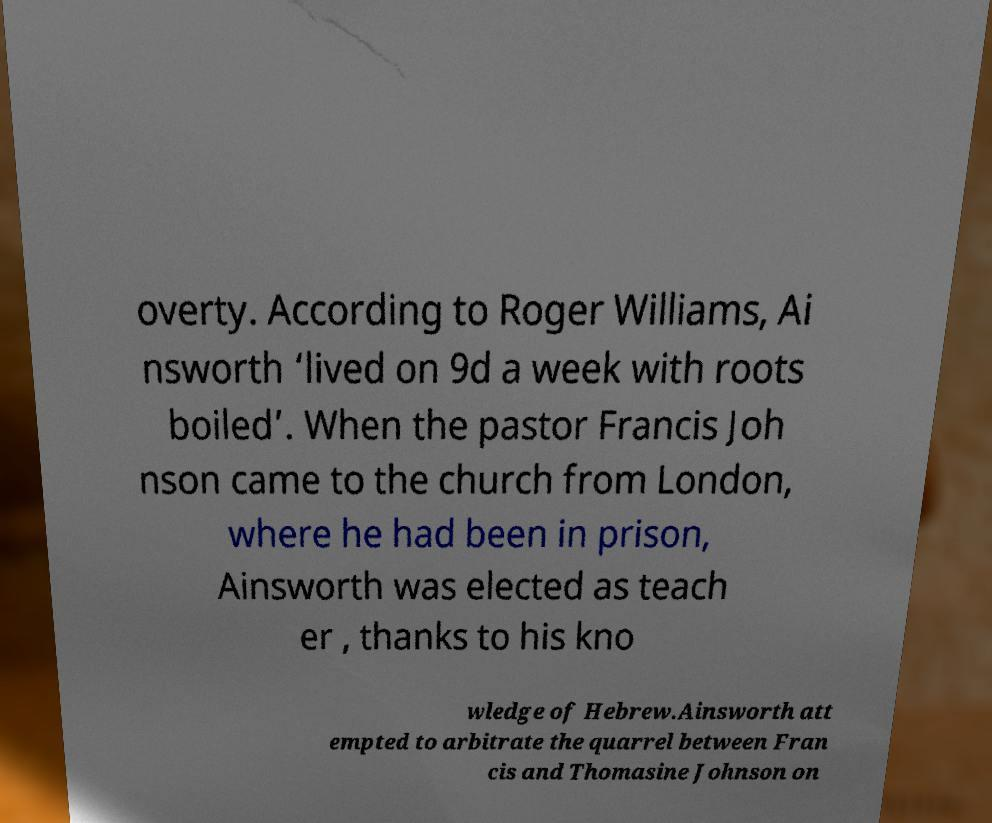I need the written content from this picture converted into text. Can you do that? overty. According to Roger Williams, Ai nsworth ‘lived on 9d a week with roots boiled’. When the pastor Francis Joh nson came to the church from London, where he had been in prison, Ainsworth was elected as teach er , thanks to his kno wledge of Hebrew.Ainsworth att empted to arbitrate the quarrel between Fran cis and Thomasine Johnson on 